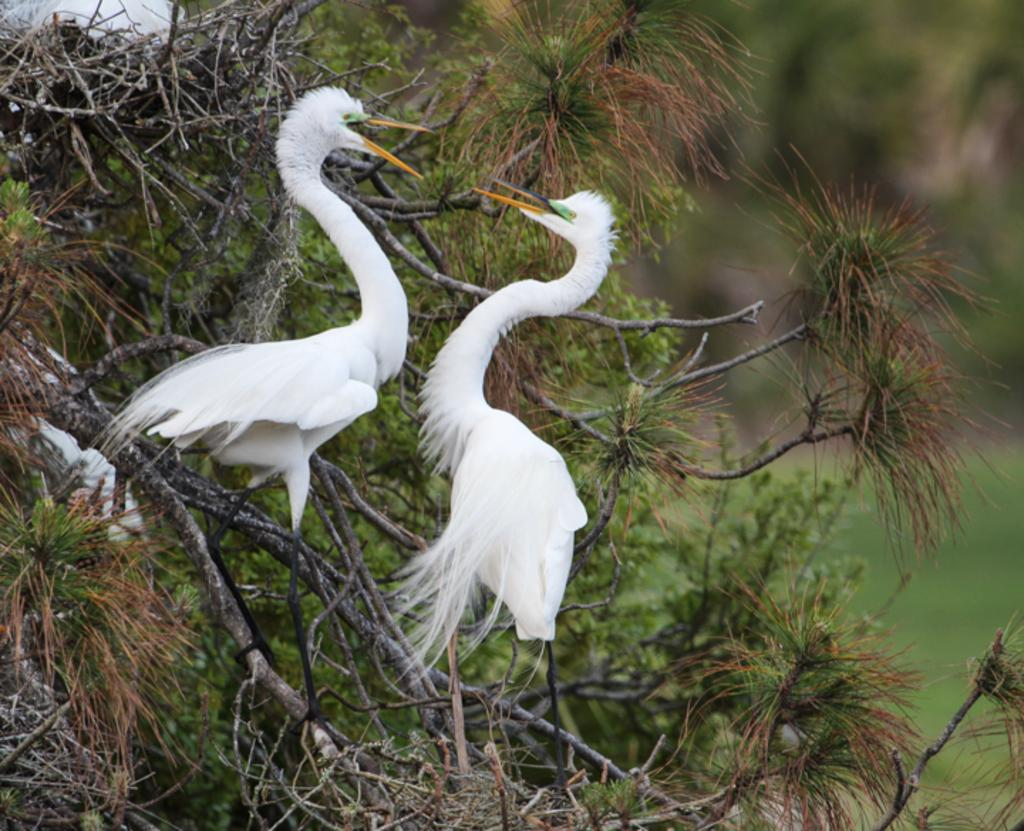What animals can be seen in the image? There are birds on a tree in the image. Can you describe the background of the image? The background of the image is blurred. What type of trouble are the girls having with the celery in the image? There are no girls or celery present in the image; it only features birds on a tree. 